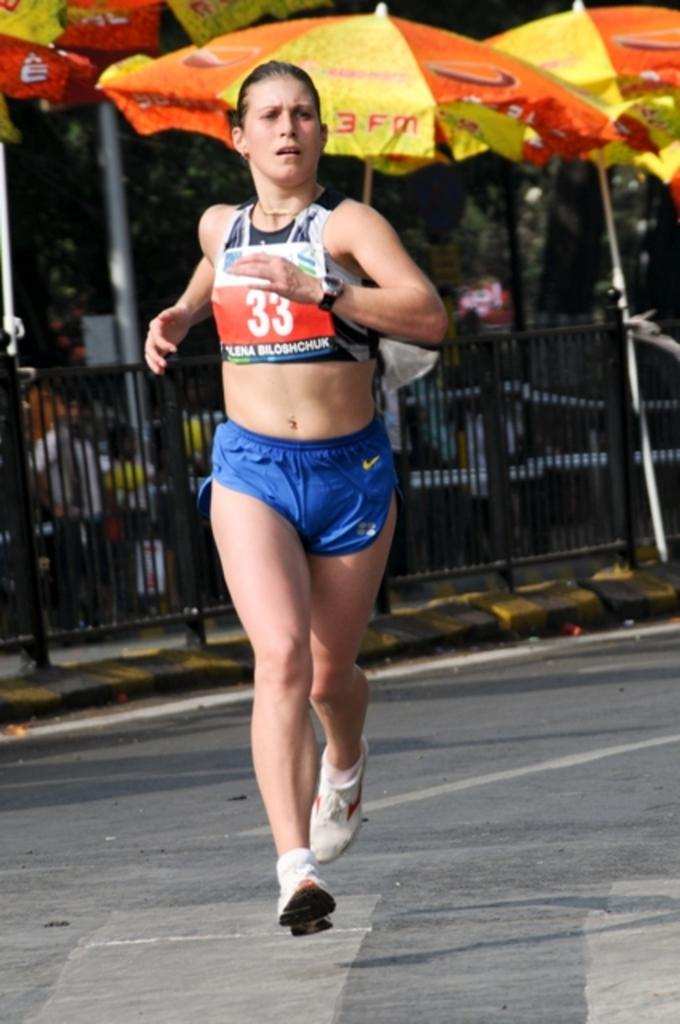<image>
Give a short and clear explanation of the subsequent image. The runner has the number 33 on her bib. 